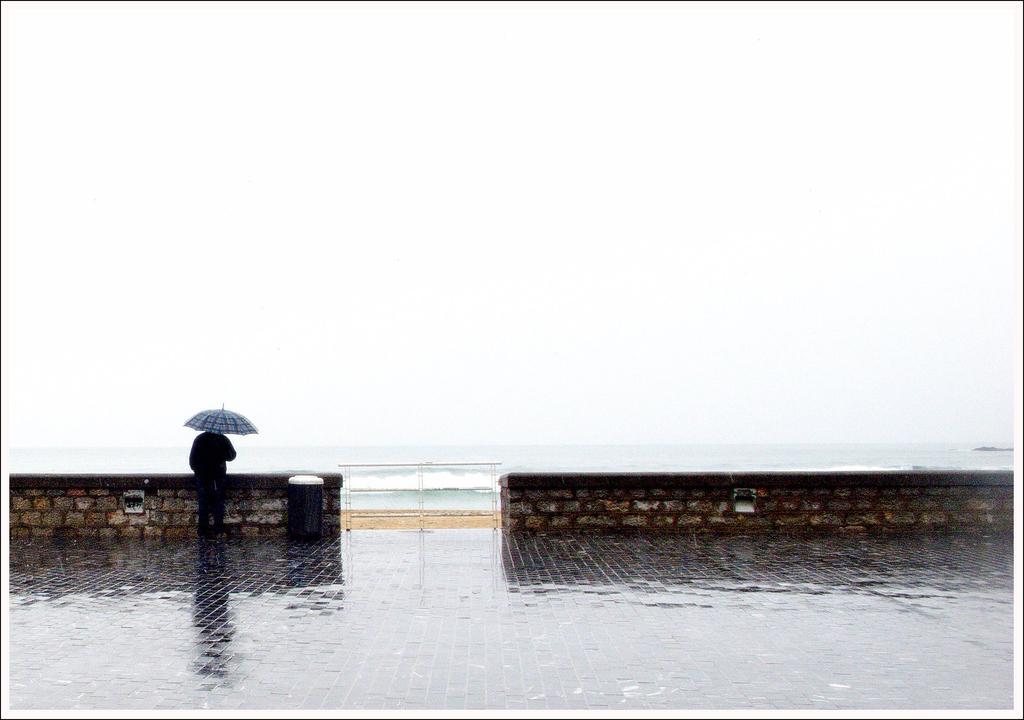Please provide a concise description of this image. In this image we can see a person standing on the floor and holding umbrella in the hands. In the background we can see sea, sky, walls with cobblestones and a bin. 